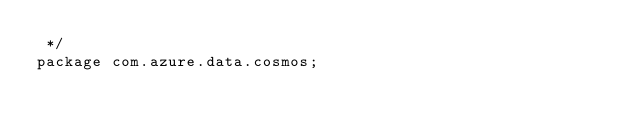<code> <loc_0><loc_0><loc_500><loc_500><_Java_> */
package com.azure.data.cosmos;</code> 